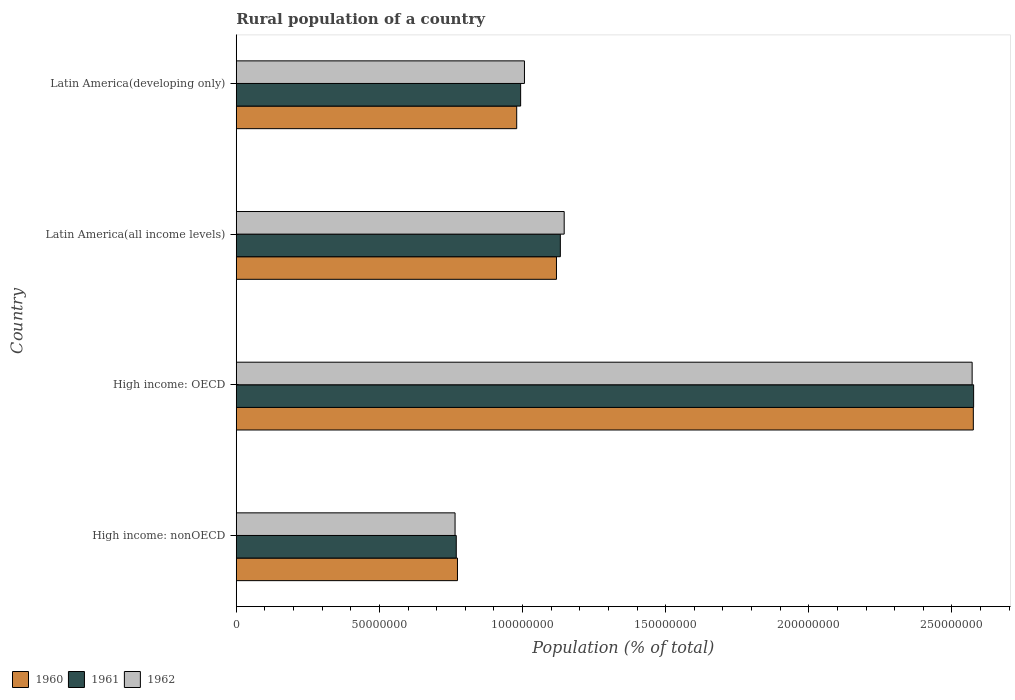How many groups of bars are there?
Give a very brief answer. 4. Are the number of bars per tick equal to the number of legend labels?
Your answer should be compact. Yes. What is the label of the 1st group of bars from the top?
Make the answer very short. Latin America(developing only). What is the rural population in 1962 in Latin America(developing only)?
Your response must be concise. 1.01e+08. Across all countries, what is the maximum rural population in 1961?
Provide a short and direct response. 2.58e+08. Across all countries, what is the minimum rural population in 1961?
Make the answer very short. 7.69e+07. In which country was the rural population in 1961 maximum?
Keep it short and to the point. High income: OECD. In which country was the rural population in 1961 minimum?
Offer a very short reply. High income: nonOECD. What is the total rural population in 1961 in the graph?
Offer a very short reply. 5.47e+08. What is the difference between the rural population in 1961 in High income: nonOECD and that in Latin America(developing only)?
Your answer should be very brief. -2.25e+07. What is the difference between the rural population in 1961 in Latin America(all income levels) and the rural population in 1960 in Latin America(developing only)?
Keep it short and to the point. 1.52e+07. What is the average rural population in 1962 per country?
Offer a very short reply. 1.37e+08. What is the difference between the rural population in 1962 and rural population in 1960 in High income: OECD?
Your answer should be very brief. -4.13e+05. In how many countries, is the rural population in 1962 greater than 110000000 %?
Provide a succinct answer. 2. What is the ratio of the rural population in 1962 in High income: OECD to that in High income: nonOECD?
Provide a short and direct response. 3.36. What is the difference between the highest and the second highest rural population in 1961?
Your answer should be very brief. 1.44e+08. What is the difference between the highest and the lowest rural population in 1961?
Your response must be concise. 1.81e+08. In how many countries, is the rural population in 1960 greater than the average rural population in 1960 taken over all countries?
Give a very brief answer. 1. Is it the case that in every country, the sum of the rural population in 1961 and rural population in 1962 is greater than the rural population in 1960?
Make the answer very short. Yes. How many bars are there?
Provide a short and direct response. 12. Are all the bars in the graph horizontal?
Offer a very short reply. Yes. What is the difference between two consecutive major ticks on the X-axis?
Your answer should be very brief. 5.00e+07. Does the graph contain grids?
Keep it short and to the point. No. How many legend labels are there?
Offer a terse response. 3. What is the title of the graph?
Your answer should be very brief. Rural population of a country. Does "2015" appear as one of the legend labels in the graph?
Your answer should be compact. No. What is the label or title of the X-axis?
Your response must be concise. Population (% of total). What is the label or title of the Y-axis?
Give a very brief answer. Country. What is the Population (% of total) in 1960 in High income: nonOECD?
Offer a terse response. 7.73e+07. What is the Population (% of total) in 1961 in High income: nonOECD?
Your answer should be very brief. 7.69e+07. What is the Population (% of total) of 1962 in High income: nonOECD?
Give a very brief answer. 7.64e+07. What is the Population (% of total) in 1960 in High income: OECD?
Provide a short and direct response. 2.57e+08. What is the Population (% of total) of 1961 in High income: OECD?
Keep it short and to the point. 2.58e+08. What is the Population (% of total) in 1962 in High income: OECD?
Make the answer very short. 2.57e+08. What is the Population (% of total) of 1960 in Latin America(all income levels)?
Ensure brevity in your answer.  1.12e+08. What is the Population (% of total) in 1961 in Latin America(all income levels)?
Ensure brevity in your answer.  1.13e+08. What is the Population (% of total) in 1962 in Latin America(all income levels)?
Your answer should be very brief. 1.15e+08. What is the Population (% of total) in 1960 in Latin America(developing only)?
Your answer should be compact. 9.80e+07. What is the Population (% of total) in 1961 in Latin America(developing only)?
Provide a short and direct response. 9.93e+07. What is the Population (% of total) of 1962 in Latin America(developing only)?
Ensure brevity in your answer.  1.01e+08. Across all countries, what is the maximum Population (% of total) of 1960?
Your answer should be very brief. 2.57e+08. Across all countries, what is the maximum Population (% of total) of 1961?
Provide a succinct answer. 2.58e+08. Across all countries, what is the maximum Population (% of total) in 1962?
Your response must be concise. 2.57e+08. Across all countries, what is the minimum Population (% of total) in 1960?
Provide a short and direct response. 7.73e+07. Across all countries, what is the minimum Population (% of total) in 1961?
Provide a succinct answer. 7.69e+07. Across all countries, what is the minimum Population (% of total) of 1962?
Your answer should be compact. 7.64e+07. What is the total Population (% of total) in 1960 in the graph?
Give a very brief answer. 5.45e+08. What is the total Population (% of total) of 1961 in the graph?
Provide a short and direct response. 5.47e+08. What is the total Population (% of total) in 1962 in the graph?
Make the answer very short. 5.49e+08. What is the difference between the Population (% of total) of 1960 in High income: nonOECD and that in High income: OECD?
Offer a very short reply. -1.80e+08. What is the difference between the Population (% of total) of 1961 in High income: nonOECD and that in High income: OECD?
Offer a terse response. -1.81e+08. What is the difference between the Population (% of total) in 1962 in High income: nonOECD and that in High income: OECD?
Your answer should be very brief. -1.81e+08. What is the difference between the Population (% of total) in 1960 in High income: nonOECD and that in Latin America(all income levels)?
Make the answer very short. -3.46e+07. What is the difference between the Population (% of total) in 1961 in High income: nonOECD and that in Latin America(all income levels)?
Offer a very short reply. -3.64e+07. What is the difference between the Population (% of total) in 1962 in High income: nonOECD and that in Latin America(all income levels)?
Keep it short and to the point. -3.81e+07. What is the difference between the Population (% of total) of 1960 in High income: nonOECD and that in Latin America(developing only)?
Keep it short and to the point. -2.07e+07. What is the difference between the Population (% of total) of 1961 in High income: nonOECD and that in Latin America(developing only)?
Ensure brevity in your answer.  -2.25e+07. What is the difference between the Population (% of total) of 1962 in High income: nonOECD and that in Latin America(developing only)?
Provide a short and direct response. -2.42e+07. What is the difference between the Population (% of total) in 1960 in High income: OECD and that in Latin America(all income levels)?
Offer a very short reply. 1.46e+08. What is the difference between the Population (% of total) of 1961 in High income: OECD and that in Latin America(all income levels)?
Provide a short and direct response. 1.44e+08. What is the difference between the Population (% of total) in 1962 in High income: OECD and that in Latin America(all income levels)?
Offer a terse response. 1.43e+08. What is the difference between the Population (% of total) of 1960 in High income: OECD and that in Latin America(developing only)?
Offer a terse response. 1.60e+08. What is the difference between the Population (% of total) in 1961 in High income: OECD and that in Latin America(developing only)?
Provide a short and direct response. 1.58e+08. What is the difference between the Population (% of total) in 1962 in High income: OECD and that in Latin America(developing only)?
Keep it short and to the point. 1.56e+08. What is the difference between the Population (% of total) of 1960 in Latin America(all income levels) and that in Latin America(developing only)?
Offer a terse response. 1.39e+07. What is the difference between the Population (% of total) in 1961 in Latin America(all income levels) and that in Latin America(developing only)?
Provide a short and direct response. 1.39e+07. What is the difference between the Population (% of total) in 1962 in Latin America(all income levels) and that in Latin America(developing only)?
Make the answer very short. 1.39e+07. What is the difference between the Population (% of total) of 1960 in High income: nonOECD and the Population (% of total) of 1961 in High income: OECD?
Offer a terse response. -1.80e+08. What is the difference between the Population (% of total) in 1960 in High income: nonOECD and the Population (% of total) in 1962 in High income: OECD?
Make the answer very short. -1.80e+08. What is the difference between the Population (% of total) of 1961 in High income: nonOECD and the Population (% of total) of 1962 in High income: OECD?
Your answer should be very brief. -1.80e+08. What is the difference between the Population (% of total) of 1960 in High income: nonOECD and the Population (% of total) of 1961 in Latin America(all income levels)?
Give a very brief answer. -3.59e+07. What is the difference between the Population (% of total) in 1960 in High income: nonOECD and the Population (% of total) in 1962 in Latin America(all income levels)?
Your answer should be compact. -3.73e+07. What is the difference between the Population (% of total) in 1961 in High income: nonOECD and the Population (% of total) in 1962 in Latin America(all income levels)?
Make the answer very short. -3.77e+07. What is the difference between the Population (% of total) of 1960 in High income: nonOECD and the Population (% of total) of 1961 in Latin America(developing only)?
Your answer should be very brief. -2.21e+07. What is the difference between the Population (% of total) in 1960 in High income: nonOECD and the Population (% of total) in 1962 in Latin America(developing only)?
Offer a terse response. -2.34e+07. What is the difference between the Population (% of total) in 1961 in High income: nonOECD and the Population (% of total) in 1962 in Latin America(developing only)?
Offer a very short reply. -2.38e+07. What is the difference between the Population (% of total) of 1960 in High income: OECD and the Population (% of total) of 1961 in Latin America(all income levels)?
Your answer should be very brief. 1.44e+08. What is the difference between the Population (% of total) in 1960 in High income: OECD and the Population (% of total) in 1962 in Latin America(all income levels)?
Offer a very short reply. 1.43e+08. What is the difference between the Population (% of total) in 1961 in High income: OECD and the Population (% of total) in 1962 in Latin America(all income levels)?
Give a very brief answer. 1.43e+08. What is the difference between the Population (% of total) of 1960 in High income: OECD and the Population (% of total) of 1961 in Latin America(developing only)?
Provide a short and direct response. 1.58e+08. What is the difference between the Population (% of total) in 1960 in High income: OECD and the Population (% of total) in 1962 in Latin America(developing only)?
Your answer should be very brief. 1.57e+08. What is the difference between the Population (% of total) of 1961 in High income: OECD and the Population (% of total) of 1962 in Latin America(developing only)?
Provide a short and direct response. 1.57e+08. What is the difference between the Population (% of total) in 1960 in Latin America(all income levels) and the Population (% of total) in 1961 in Latin America(developing only)?
Provide a short and direct response. 1.25e+07. What is the difference between the Population (% of total) of 1960 in Latin America(all income levels) and the Population (% of total) of 1962 in Latin America(developing only)?
Your answer should be compact. 1.12e+07. What is the difference between the Population (% of total) of 1961 in Latin America(all income levels) and the Population (% of total) of 1962 in Latin America(developing only)?
Your response must be concise. 1.25e+07. What is the average Population (% of total) of 1960 per country?
Ensure brevity in your answer.  1.36e+08. What is the average Population (% of total) of 1961 per country?
Provide a succinct answer. 1.37e+08. What is the average Population (% of total) of 1962 per country?
Give a very brief answer. 1.37e+08. What is the difference between the Population (% of total) of 1960 and Population (% of total) of 1961 in High income: nonOECD?
Make the answer very short. 4.24e+05. What is the difference between the Population (% of total) in 1960 and Population (% of total) in 1962 in High income: nonOECD?
Give a very brief answer. 8.42e+05. What is the difference between the Population (% of total) of 1961 and Population (% of total) of 1962 in High income: nonOECD?
Offer a very short reply. 4.18e+05. What is the difference between the Population (% of total) in 1960 and Population (% of total) in 1961 in High income: OECD?
Your response must be concise. -1.05e+05. What is the difference between the Population (% of total) of 1960 and Population (% of total) of 1962 in High income: OECD?
Provide a short and direct response. 4.13e+05. What is the difference between the Population (% of total) of 1961 and Population (% of total) of 1962 in High income: OECD?
Keep it short and to the point. 5.18e+05. What is the difference between the Population (% of total) of 1960 and Population (% of total) of 1961 in Latin America(all income levels)?
Your answer should be compact. -1.36e+06. What is the difference between the Population (% of total) in 1960 and Population (% of total) in 1962 in Latin America(all income levels)?
Provide a succinct answer. -2.70e+06. What is the difference between the Population (% of total) in 1961 and Population (% of total) in 1962 in Latin America(all income levels)?
Your answer should be compact. -1.34e+06. What is the difference between the Population (% of total) of 1960 and Population (% of total) of 1961 in Latin America(developing only)?
Your answer should be very brief. -1.37e+06. What is the difference between the Population (% of total) in 1960 and Population (% of total) in 1962 in Latin America(developing only)?
Offer a very short reply. -2.71e+06. What is the difference between the Population (% of total) in 1961 and Population (% of total) in 1962 in Latin America(developing only)?
Provide a succinct answer. -1.33e+06. What is the ratio of the Population (% of total) in 1960 in High income: nonOECD to that in High income: OECD?
Your response must be concise. 0.3. What is the ratio of the Population (% of total) of 1961 in High income: nonOECD to that in High income: OECD?
Your answer should be very brief. 0.3. What is the ratio of the Population (% of total) in 1962 in High income: nonOECD to that in High income: OECD?
Keep it short and to the point. 0.3. What is the ratio of the Population (% of total) in 1960 in High income: nonOECD to that in Latin America(all income levels)?
Your response must be concise. 0.69. What is the ratio of the Population (% of total) in 1961 in High income: nonOECD to that in Latin America(all income levels)?
Give a very brief answer. 0.68. What is the ratio of the Population (% of total) in 1962 in High income: nonOECD to that in Latin America(all income levels)?
Give a very brief answer. 0.67. What is the ratio of the Population (% of total) of 1960 in High income: nonOECD to that in Latin America(developing only)?
Your answer should be compact. 0.79. What is the ratio of the Population (% of total) of 1961 in High income: nonOECD to that in Latin America(developing only)?
Give a very brief answer. 0.77. What is the ratio of the Population (% of total) in 1962 in High income: nonOECD to that in Latin America(developing only)?
Give a very brief answer. 0.76. What is the ratio of the Population (% of total) in 1960 in High income: OECD to that in Latin America(all income levels)?
Make the answer very short. 2.3. What is the ratio of the Population (% of total) in 1961 in High income: OECD to that in Latin America(all income levels)?
Offer a very short reply. 2.28. What is the ratio of the Population (% of total) in 1962 in High income: OECD to that in Latin America(all income levels)?
Provide a short and direct response. 2.24. What is the ratio of the Population (% of total) in 1960 in High income: OECD to that in Latin America(developing only)?
Ensure brevity in your answer.  2.63. What is the ratio of the Population (% of total) in 1961 in High income: OECD to that in Latin America(developing only)?
Ensure brevity in your answer.  2.59. What is the ratio of the Population (% of total) in 1962 in High income: OECD to that in Latin America(developing only)?
Your answer should be very brief. 2.55. What is the ratio of the Population (% of total) in 1960 in Latin America(all income levels) to that in Latin America(developing only)?
Offer a very short reply. 1.14. What is the ratio of the Population (% of total) of 1961 in Latin America(all income levels) to that in Latin America(developing only)?
Ensure brevity in your answer.  1.14. What is the ratio of the Population (% of total) in 1962 in Latin America(all income levels) to that in Latin America(developing only)?
Your answer should be compact. 1.14. What is the difference between the highest and the second highest Population (% of total) of 1960?
Make the answer very short. 1.46e+08. What is the difference between the highest and the second highest Population (% of total) in 1961?
Provide a short and direct response. 1.44e+08. What is the difference between the highest and the second highest Population (% of total) in 1962?
Give a very brief answer. 1.43e+08. What is the difference between the highest and the lowest Population (% of total) in 1960?
Ensure brevity in your answer.  1.80e+08. What is the difference between the highest and the lowest Population (% of total) of 1961?
Provide a short and direct response. 1.81e+08. What is the difference between the highest and the lowest Population (% of total) of 1962?
Offer a terse response. 1.81e+08. 